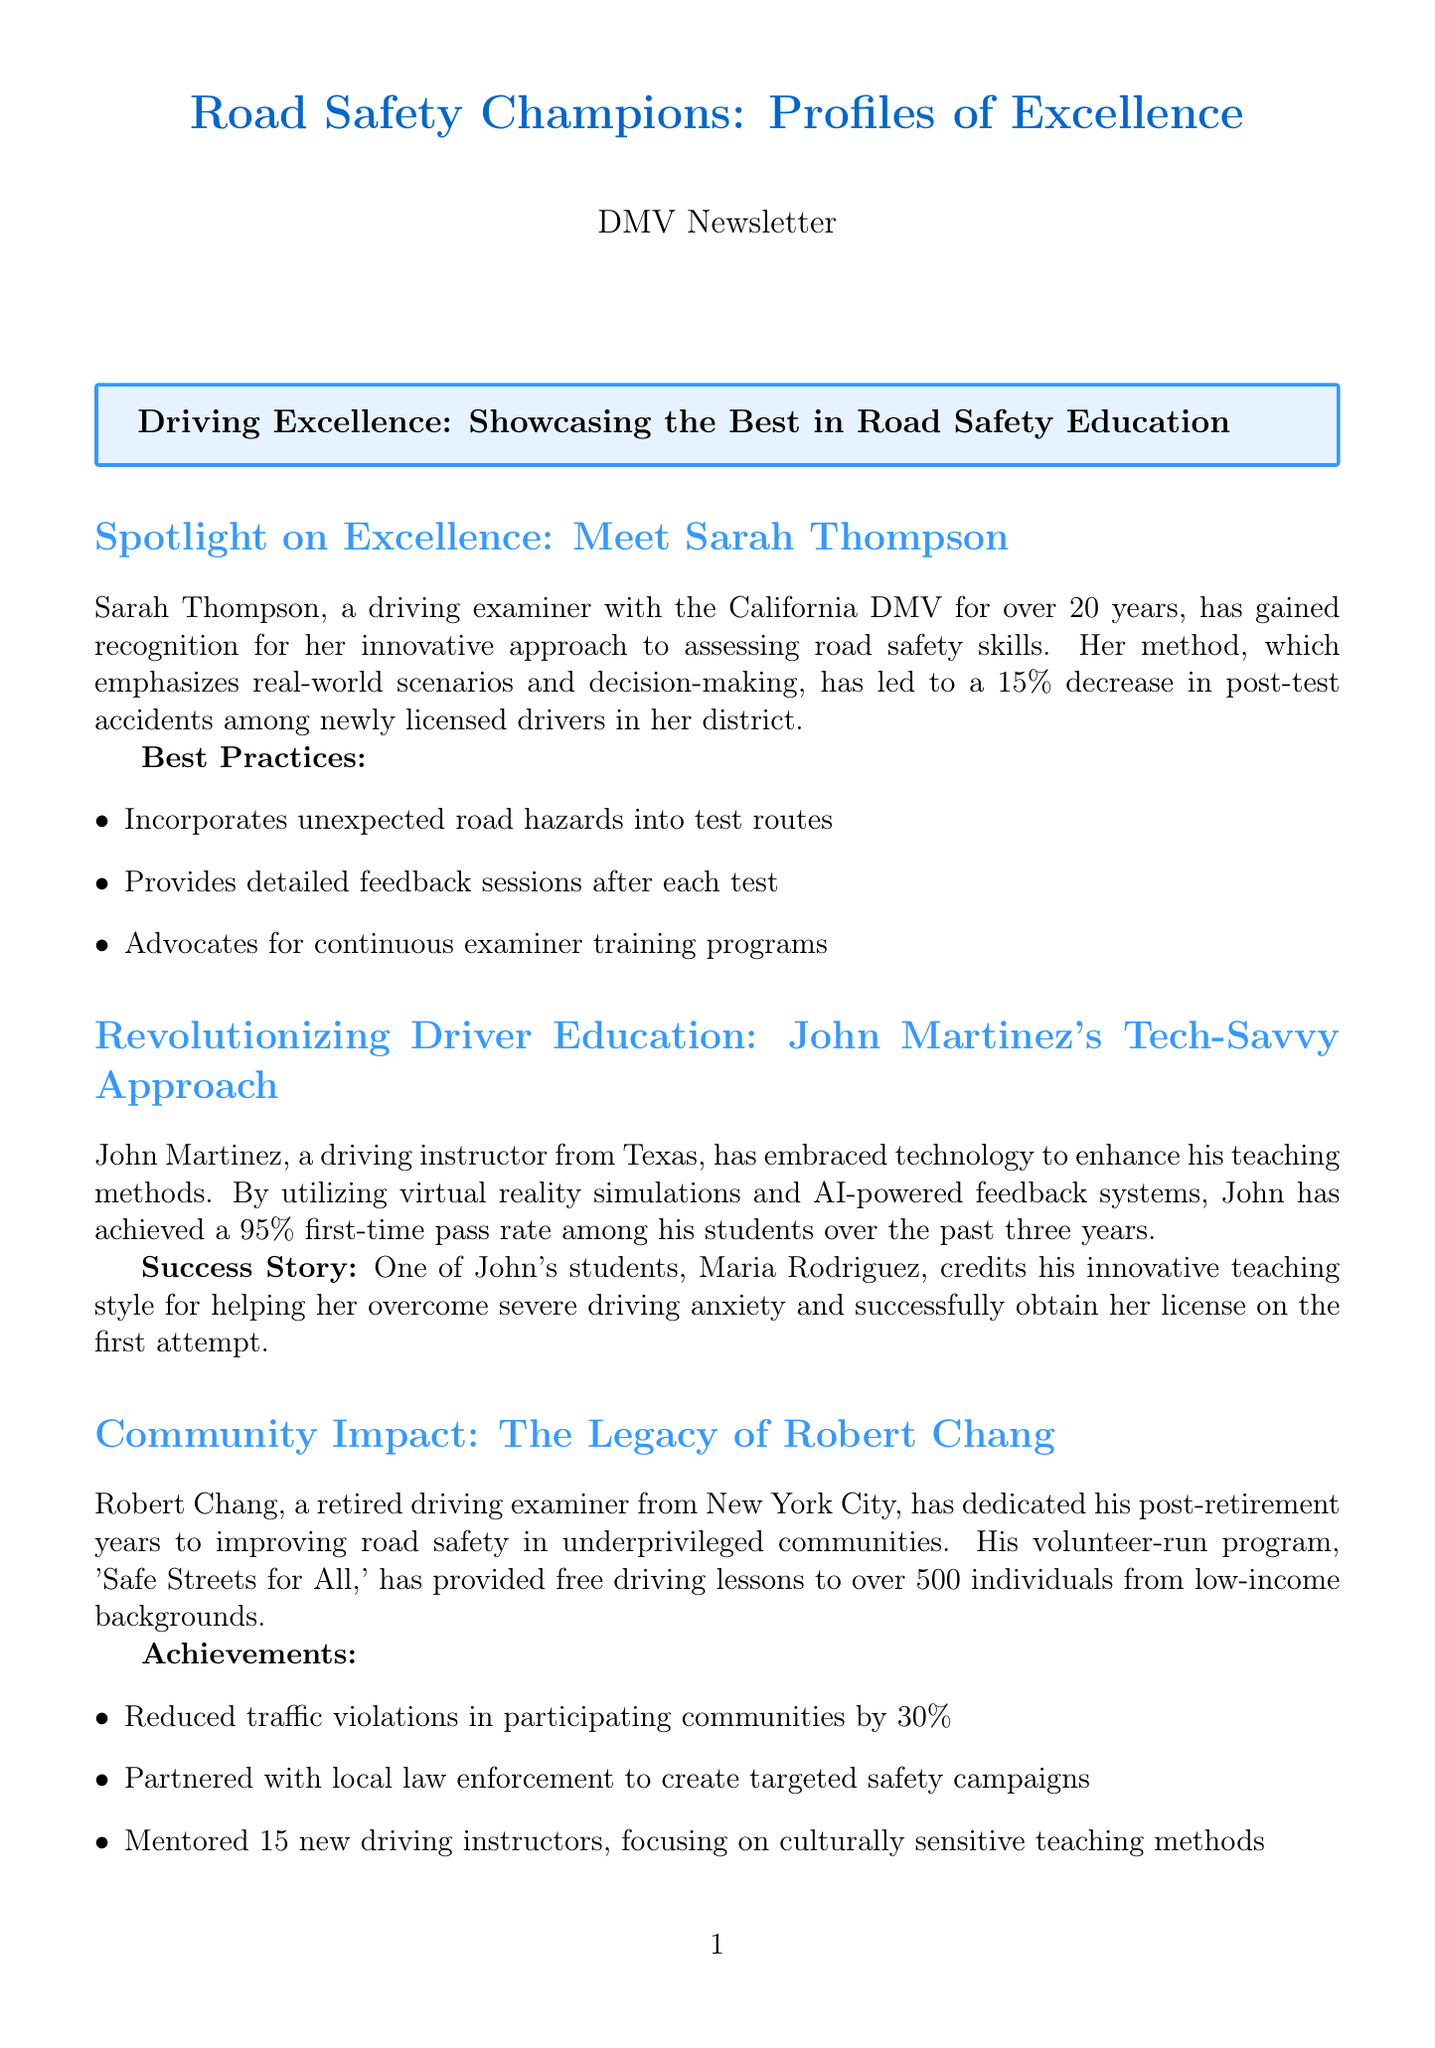What is Sarah Thompson's role? Sarah Thompson is recognized for her innovative approach as a driving examiner with the California DMV.
Answer: Driving examiner What percentage decrease in post-test accidents is attributed to Sarah Thompson's method? The document states that her method led to a 15% decrease in post-test accidents among newly licensed drivers.
Answer: 15% What teaching method does John Martinez use? John Martinez utilizes virtual reality simulations and AI-powered feedback systems to enhance his teaching methods.
Answer: Technology How many individuals has Robert Chang provided free driving lessons to? Robert Chang's program has provided free driving lessons to over 500 individuals from low-income backgrounds.
Answer: Over 500 What is the name of Carlos Mendoza's initiative for individuals with disabilities? The text mentions that Carlos Mendoza has made strides in making driver education accessible, but it does not specify an initiative name.
Answer: N/A Which city is Emma Wilson associated with? Emma Wilson is recognized as a driving examiner from Seattle.
Answer: Seattle What is a key contribution of Emma Wilson? Emma Wilson developed a comprehensive ADAS assessment module for driving tests as a significant part of her contributions.
Answer: ADAS assessment module How many new driving instructors did Robert Chang mentor? Robert Chang mentored 15 new driving instructors, focusing on culturally sensitive teaching methods.
Answer: 15 What is the goal of Carlos Mendoza's methods? Carlos Mendoza's customized teaching methods aim to make driver education accessible to individuals with disabilities.
Answer: Accessibility What notable statistic reflects John Martinez's teaching success? John Martinez has achieved a 95% first-time pass rate among his students over the past three years, highlighting his teaching success.
Answer: 95% 